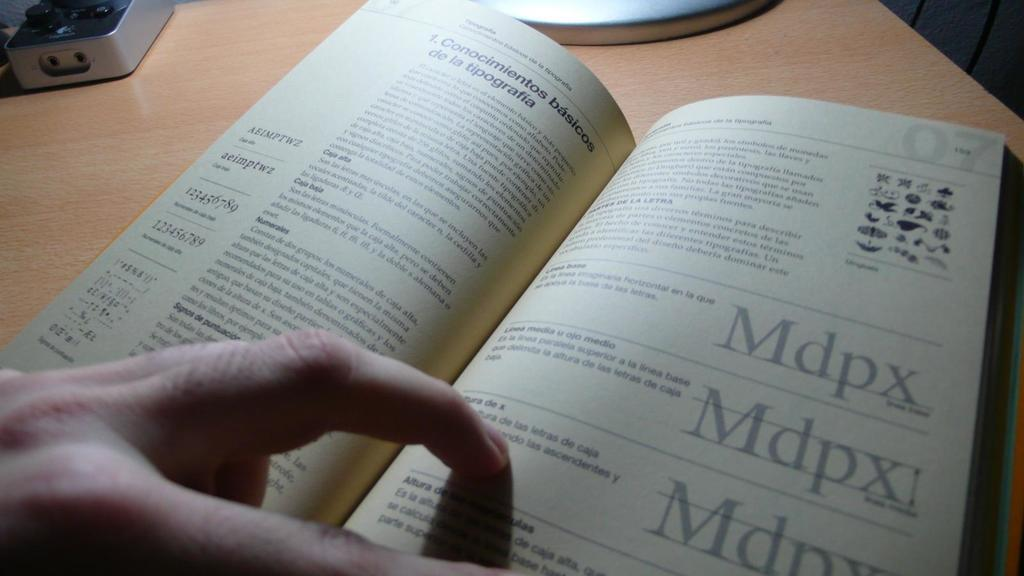<image>
Write a terse but informative summary of the picture. A person is reading a book that says Mdpx. 